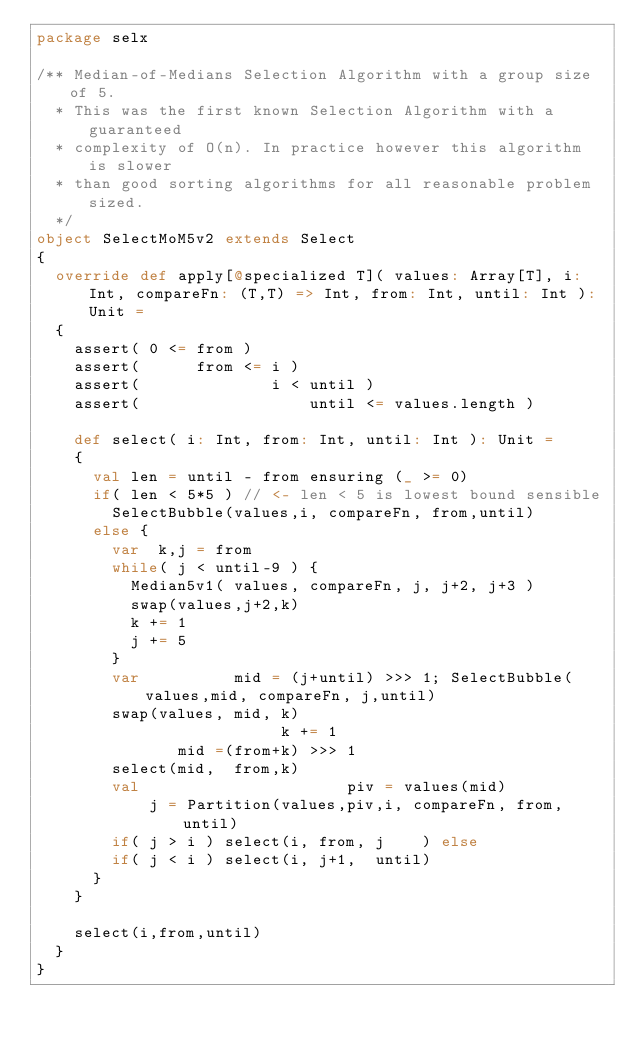Convert code to text. <code><loc_0><loc_0><loc_500><loc_500><_Scala_>package selx

/** Median-of-Medians Selection Algorithm with a group size of 5.
  * This was the first known Selection Algorithm with a guaranteed
  * complexity of O(n). In practice however this algorithm is slower
  * than good sorting algorithms for all reasonable problem sized.
  */
object SelectMoM5v2 extends Select
{
  override def apply[@specialized T]( values: Array[T], i: Int, compareFn: (T,T) => Int, from: Int, until: Int ): Unit =
  {
    assert( 0 <= from )
    assert(      from <= i )
    assert(              i < until )
    assert(                  until <= values.length )

    def select( i: Int, from: Int, until: Int ): Unit =
    {
      val len = until - from ensuring (_ >= 0)
      if( len < 5*5 ) // <- len < 5 is lowest bound sensible
        SelectBubble(values,i, compareFn, from,until)
      else {
        var  k,j = from
        while( j < until-9 ) {
          Median5v1( values, compareFn, j, j+2, j+3 )
          swap(values,j+2,k)
          k += 1
          j += 5
        }
        var          mid = (j+until) >>> 1; SelectBubble(values,mid, compareFn, j,until)
        swap(values, mid, k)
                          k += 1
               mid =(from+k) >>> 1
        select(mid,  from,k)
        val                      piv = values(mid)
            j = Partition(values,piv,i, compareFn, from,until)
        if( j > i ) select(i, from, j    ) else
        if( j < i ) select(i, j+1,  until)
      }
    }

    select(i,from,until)
  }
}
</code> 